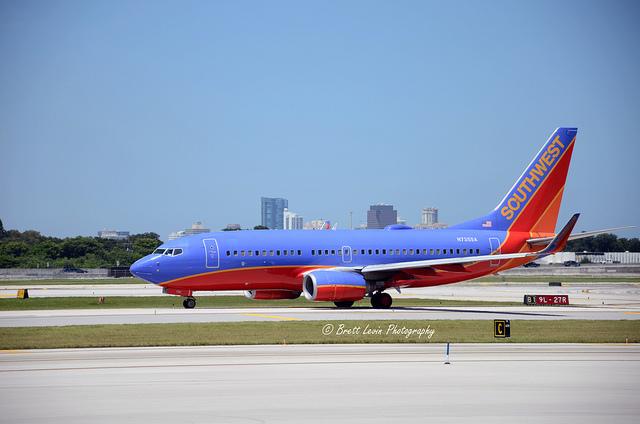Is the plane in motion?
Quick response, please. No. What does the plane's tail read?
Give a very brief answer. Southwest. What country is the airline based out of?
Quick response, please. Usa. What airline is this plane flying?
Answer briefly. Southwest. 